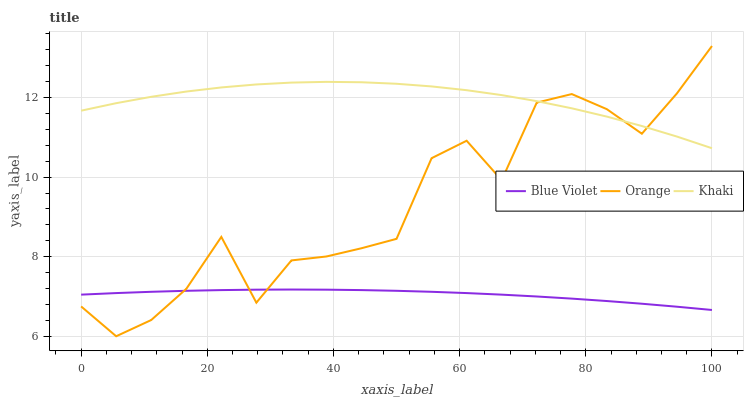Does Blue Violet have the minimum area under the curve?
Answer yes or no. Yes. Does Khaki have the maximum area under the curve?
Answer yes or no. Yes. Does Khaki have the minimum area under the curve?
Answer yes or no. No. Does Blue Violet have the maximum area under the curve?
Answer yes or no. No. Is Blue Violet the smoothest?
Answer yes or no. Yes. Is Orange the roughest?
Answer yes or no. Yes. Is Khaki the smoothest?
Answer yes or no. No. Is Khaki the roughest?
Answer yes or no. No. Does Orange have the lowest value?
Answer yes or no. Yes. Does Blue Violet have the lowest value?
Answer yes or no. No. Does Orange have the highest value?
Answer yes or no. Yes. Does Khaki have the highest value?
Answer yes or no. No. Is Blue Violet less than Khaki?
Answer yes or no. Yes. Is Khaki greater than Blue Violet?
Answer yes or no. Yes. Does Blue Violet intersect Orange?
Answer yes or no. Yes. Is Blue Violet less than Orange?
Answer yes or no. No. Is Blue Violet greater than Orange?
Answer yes or no. No. Does Blue Violet intersect Khaki?
Answer yes or no. No. 